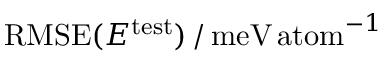<formula> <loc_0><loc_0><loc_500><loc_500>R M S E ( E ^ { t e s t } ) \, / \, m e V \, a t o m ^ { - 1 }</formula> 